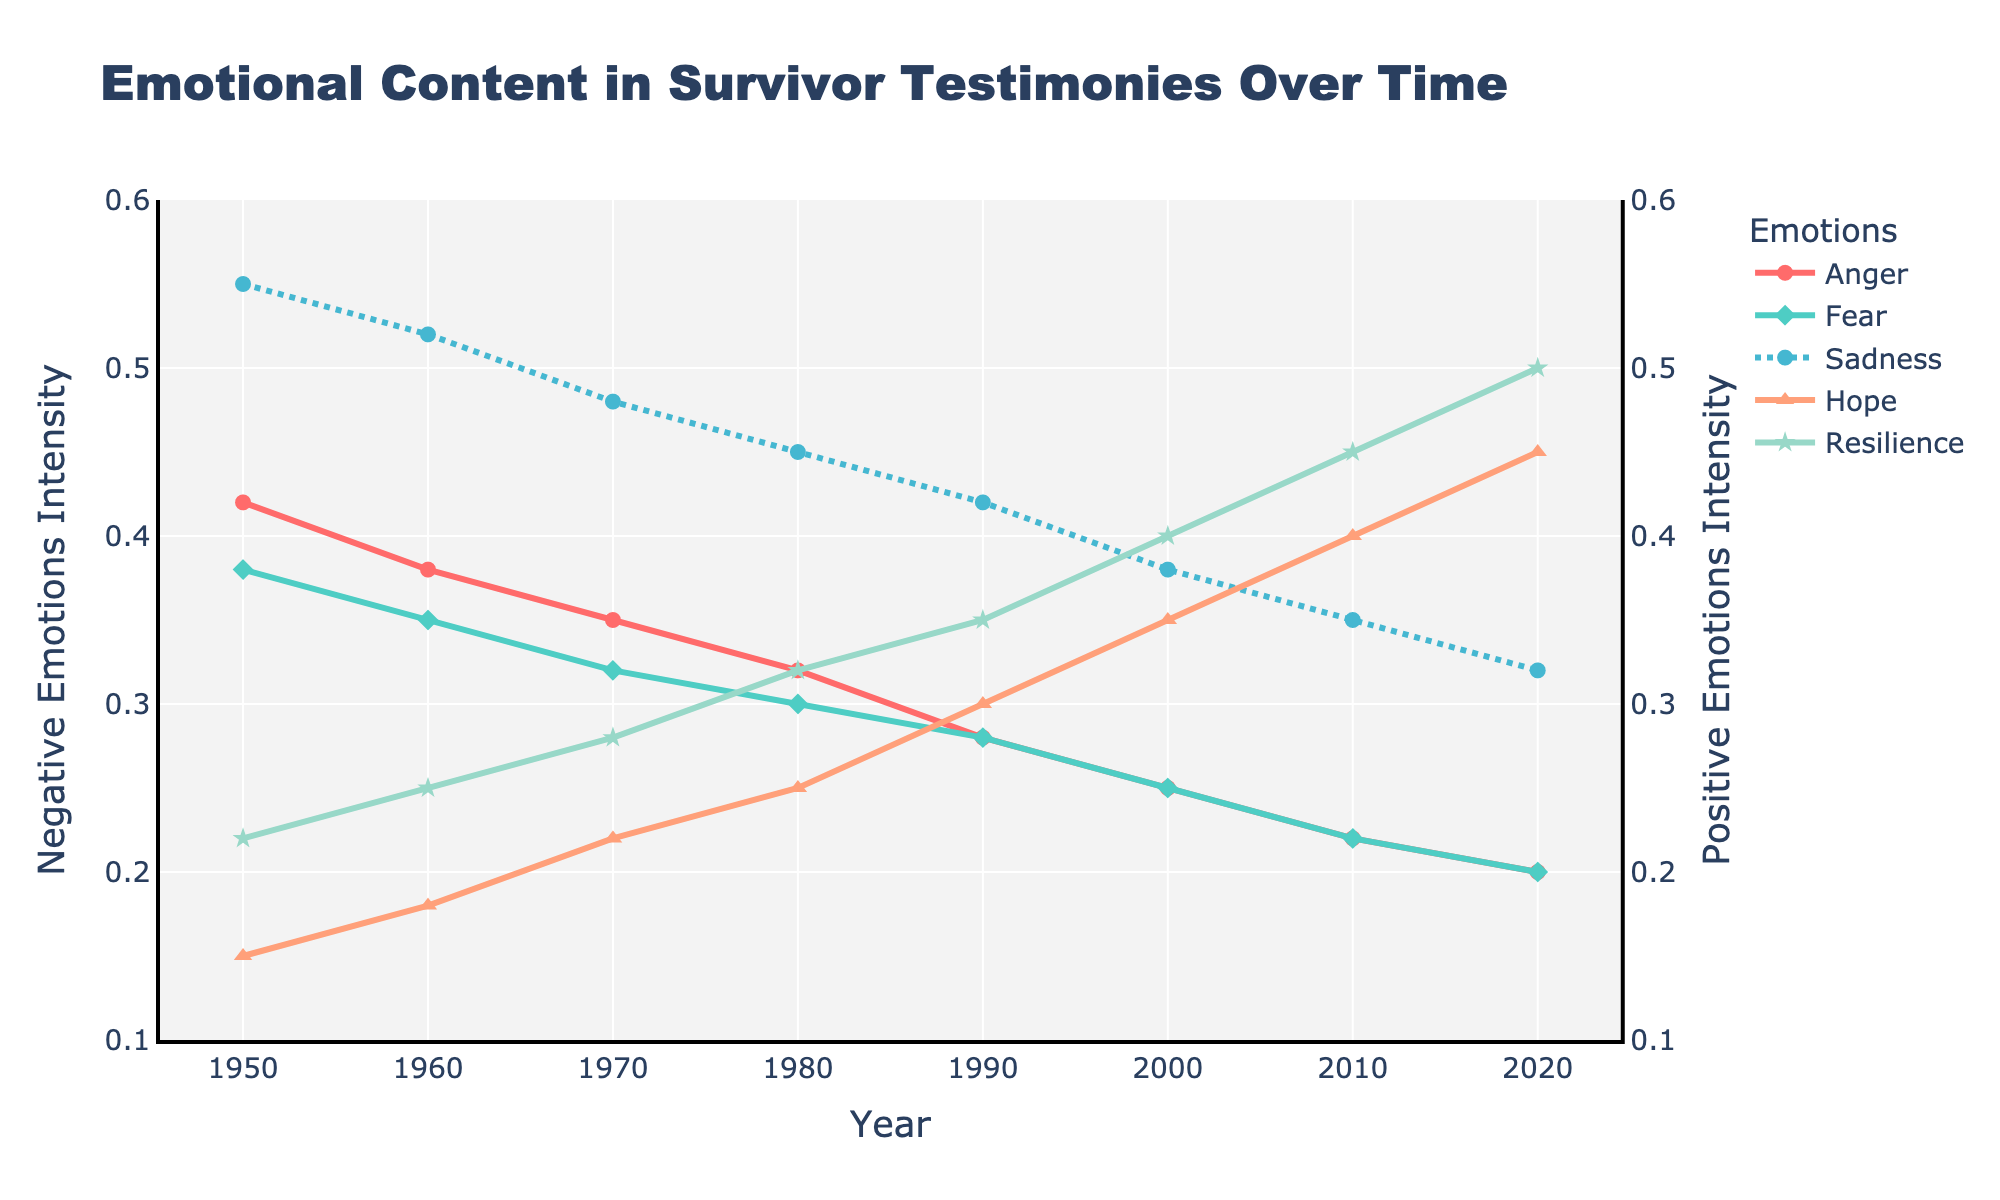What is the overall trend in anger from 1950 to 2020? The anger line shows a decreasing trend over the years from 0.42 in 1950 to 0.20 in 2020. This is visible by looking at the downward slope of the line.
Answer: Decreasing Compare the levels of sadness and hope in the year 2000. Which is higher? In the year 2000, the sadness level is 0.38 and the hope level is 0.35. Therefore, sadness is higher than hope in that year.
Answer: Sadness Which emotion shows the most significant increase from 1950 to 2020? By comparing the initial and final values of all emotions, resilience shows the most significant increase, starting at 0.22 and reaching 0.50 in 2020.
Answer: Resilience In which decade do hope and resilience first surpass any of the negative emotions? Hope surpasses fear and sadness in the 1990s, where hope is at 0.30, resilience at 0.35, while fear and sadness are at 0.28 and 0.42, respectively.
Answer: 1990s By how much did the level of fear decrease from 1950 to 1980? The level of fear decreased from 0.38 in 1950 to 0.30 in 1980, a total decrease of 0.38 - 0.30 = 0.08.
Answer: 0.08 What can be inferred about the combined level (sum) of anger and fear in 2020 compared to the combined level of hope and resilience in 2020? In 2020, the combined level of anger (0.20) and fear (0.20) is 0.40. The combined level of hope (0.45) and resilience (0.50) is 0.95. Therefore, hope and resilience combined are higher than anger and fear combined.
Answer: Higher During which decade do all negative emotions (anger, fear, and sadness) fall below 0.30? In the 2000s, anger is at 0.25, fear is at 0.25, and sadness is at 0.38. By the 2010s, all negative emotions fall below 0.30: anger at 0.22, fear at 0.22, and sadness at 0.35. Thus, the decade is 2010s.
Answer: 2010s How does the intensity of resilience in 1970 compare to hope in 1990? In 1970, the intensity of resilience is at 0.28, while hope in 1990 is at 0.30. Therefore, hope in 1990 is higher than resilience in 1970.
Answer: Hope in 1990 is higher What is the ratio of sadness to hope in 1950? In 1950, the level of sadness is 0.55 and hope is 0.15. The ratio of sadness to hope is 0.55 / 0.15 = 3.67.
Answer: 3.67 What trend is observed in the intensity of positive emotions (hope and resilience) over the decades? Both hope and resilience show an increasing trend. Hope goes from 0.15 in 1950 to 0.45 in 2020, and resilience goes from 0.22 in 1950 to 0.50 in 2020.
Answer: Increasing 